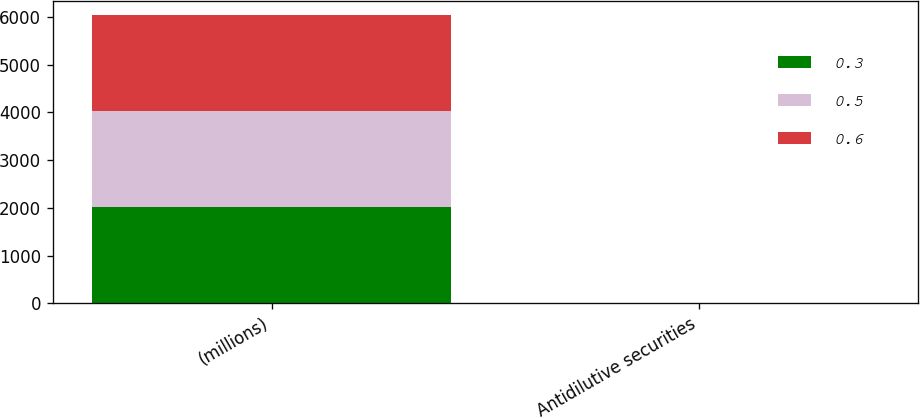Convert chart to OTSL. <chart><loc_0><loc_0><loc_500><loc_500><stacked_bar_chart><ecel><fcel>(millions)<fcel>Antidilutive securities<nl><fcel>0.3<fcel>2012<fcel>0.3<nl><fcel>0.5<fcel>2011<fcel>0.5<nl><fcel>0.6<fcel>2010<fcel>0.6<nl></chart> 